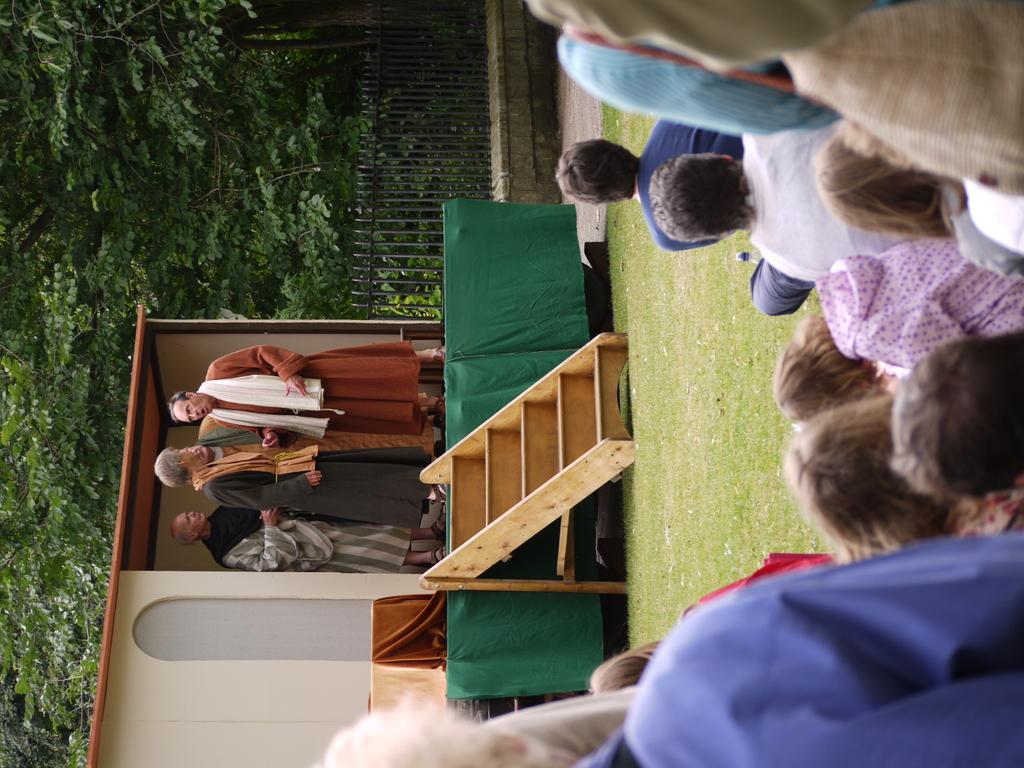Describe this image in one or two sentences. In this image there are some persons on the right side of this image and some persons are on the left side of this image. There is a stage in middle of this image, and there is a fencing wall on the top of this image. There are some trees on the left side of this image. 